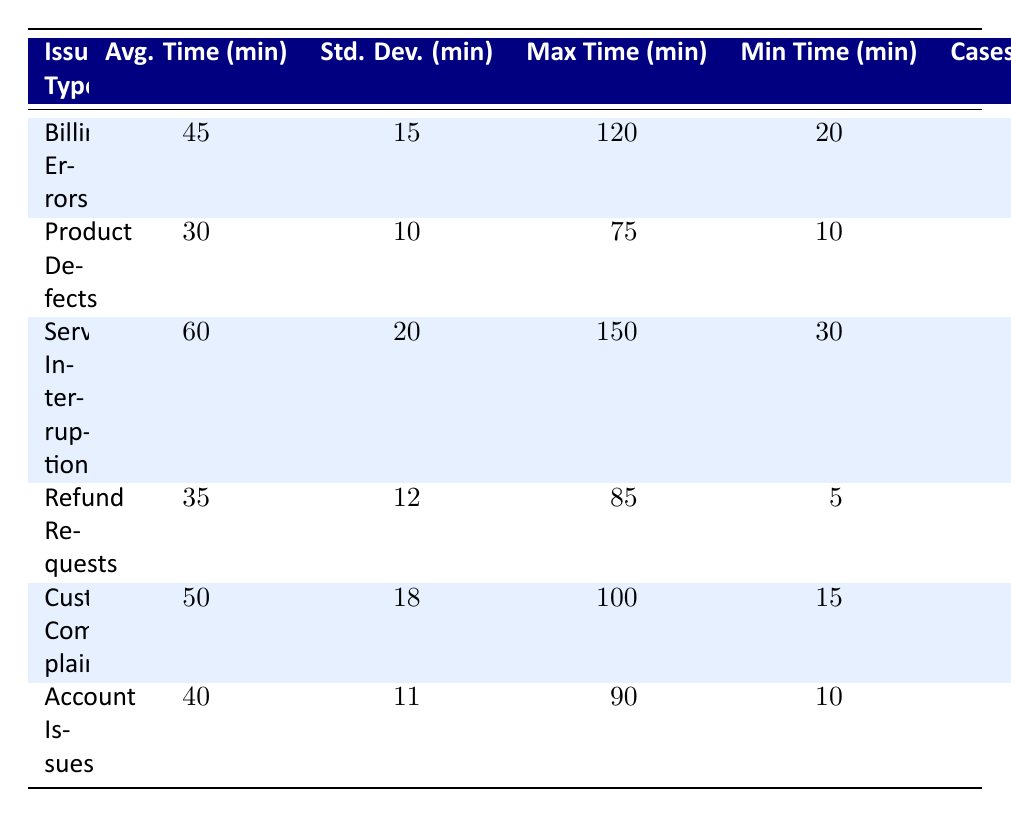What is the average resolution time for Billing Errors? From the table, the average resolution time for Billing Errors is displayed under the "Avg. Time (min)" column, which shows a value of 45 minutes.
Answer: 45 minutes How many cases were handled for Product Defects? The table indicates that 180 cases were handled for Product Defects, as listed in the "Cases Handled" column.
Answer: 180 cases Which issue type has the highest average resolution time? Comparing the average resolution times in the "Avg. Time (min)" column, Service Interruptions has the highest average time of 60 minutes.
Answer: Service Interruptions What is the minimum resolution time for Refund Requests? The minimum resolution time for Refund Requests can be found in the "Min Time (min)" column, which lists a value of 5 minutes.
Answer: 5 minutes Which issue type had the most variance in resolution times? To determine the variance, we can look at the standard deviation values in the "Std. Dev. (min)" column. Service Interruptions has a standard deviation of 20 minutes, which is the highest.
Answer: Service Interruptions Is the average resolution time for Customer Complaints greater than that for Account Issues? The average resolution time for Customer Complaints is 50 minutes, while for Account Issues it is 40 minutes. Since 50 is greater than 40, the statement is true.
Answer: Yes What is the difference between the maximum and minimum resolution times for Service Interruptions? The maximum resolution time for Service Interruptions is 150 minutes and the minimum is 30 minutes. The difference is calculated as 150 - 30 = 120 minutes.
Answer: 120 minutes Calculate the total number of cases handled across all issue types. To find the total number of cases handled, we sum the values from the "Cases Handled" column: 250 + 180 + 90 + 130 + 220 + 150 = 1020 cases.
Answer: 1020 cases True or False: The average resolution time for Product Defects is less than that for Refund Requests. The average resolution time for Product Defects is 30 minutes, while for Refund Requests it is 35 minutes. Since 30 is less than 35, the statement is true.
Answer: True What is the average resolution time for all issue types? To find the average resolution time for all types, we first calculate the total resolution time as (45 + 30 + 60 + 35 + 50 + 40) = 260 minutes. We then divide by the number of issue types (6), giving us 260/6 = approximately 43.33 minutes.
Answer: 43.33 minutes 